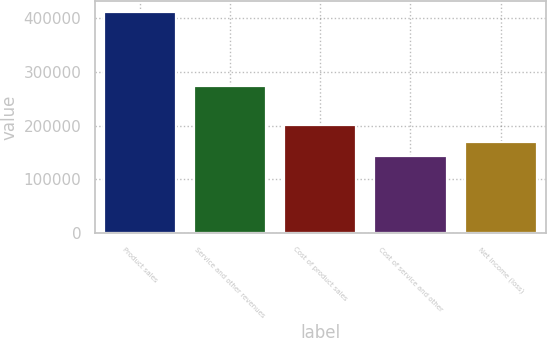Convert chart. <chart><loc_0><loc_0><loc_500><loc_500><bar_chart><fcel>Product sales<fcel>Service and other revenues<fcel>Cost of product sales<fcel>Cost of service and other<fcel>Net income (loss)<nl><fcel>411309<fcel>274197<fcel>200912<fcel>143399<fcel>170190<nl></chart> 